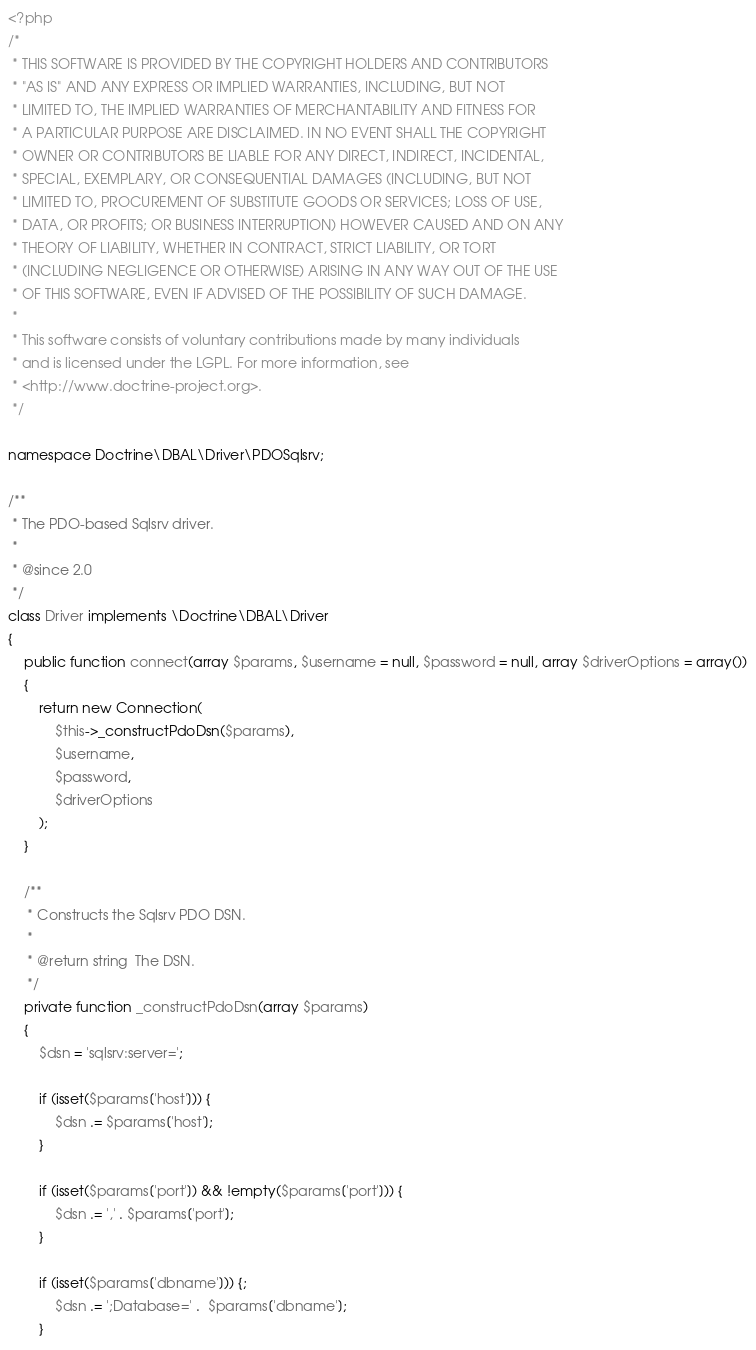Convert code to text. <code><loc_0><loc_0><loc_500><loc_500><_PHP_><?php
/*
 * THIS SOFTWARE IS PROVIDED BY THE COPYRIGHT HOLDERS AND CONTRIBUTORS
 * "AS IS" AND ANY EXPRESS OR IMPLIED WARRANTIES, INCLUDING, BUT NOT
 * LIMITED TO, THE IMPLIED WARRANTIES OF MERCHANTABILITY AND FITNESS FOR
 * A PARTICULAR PURPOSE ARE DISCLAIMED. IN NO EVENT SHALL THE COPYRIGHT
 * OWNER OR CONTRIBUTORS BE LIABLE FOR ANY DIRECT, INDIRECT, INCIDENTAL,
 * SPECIAL, EXEMPLARY, OR CONSEQUENTIAL DAMAGES (INCLUDING, BUT NOT
 * LIMITED TO, PROCUREMENT OF SUBSTITUTE GOODS OR SERVICES; LOSS OF USE,
 * DATA, OR PROFITS; OR BUSINESS INTERRUPTION) HOWEVER CAUSED AND ON ANY
 * THEORY OF LIABILITY, WHETHER IN CONTRACT, STRICT LIABILITY, OR TORT
 * (INCLUDING NEGLIGENCE OR OTHERWISE) ARISING IN ANY WAY OUT OF THE USE
 * OF THIS SOFTWARE, EVEN IF ADVISED OF THE POSSIBILITY OF SUCH DAMAGE.
 *
 * This software consists of voluntary contributions made by many individuals
 * and is licensed under the LGPL. For more information, see
 * <http://www.doctrine-project.org>.
 */

namespace Doctrine\DBAL\Driver\PDOSqlsrv;

/**
 * The PDO-based Sqlsrv driver.
 *
 * @since 2.0
 */
class Driver implements \Doctrine\DBAL\Driver
{
    public function connect(array $params, $username = null, $password = null, array $driverOptions = array())
    {
        return new Connection(
            $this->_constructPdoDsn($params),
            $username,
            $password,
            $driverOptions
        );
    }

    /**
     * Constructs the Sqlsrv PDO DSN.
     *
     * @return string  The DSN.
     */
    private function _constructPdoDsn(array $params)
    {
        $dsn = 'sqlsrv:server=';

        if (isset($params['host'])) {
            $dsn .= $params['host'];
        }

        if (isset($params['port']) && !empty($params['port'])) {
            $dsn .= ',' . $params['port'];
        }

        if (isset($params['dbname'])) {;
            $dsn .= ';Database=' .  $params['dbname'];
        }
</code> 